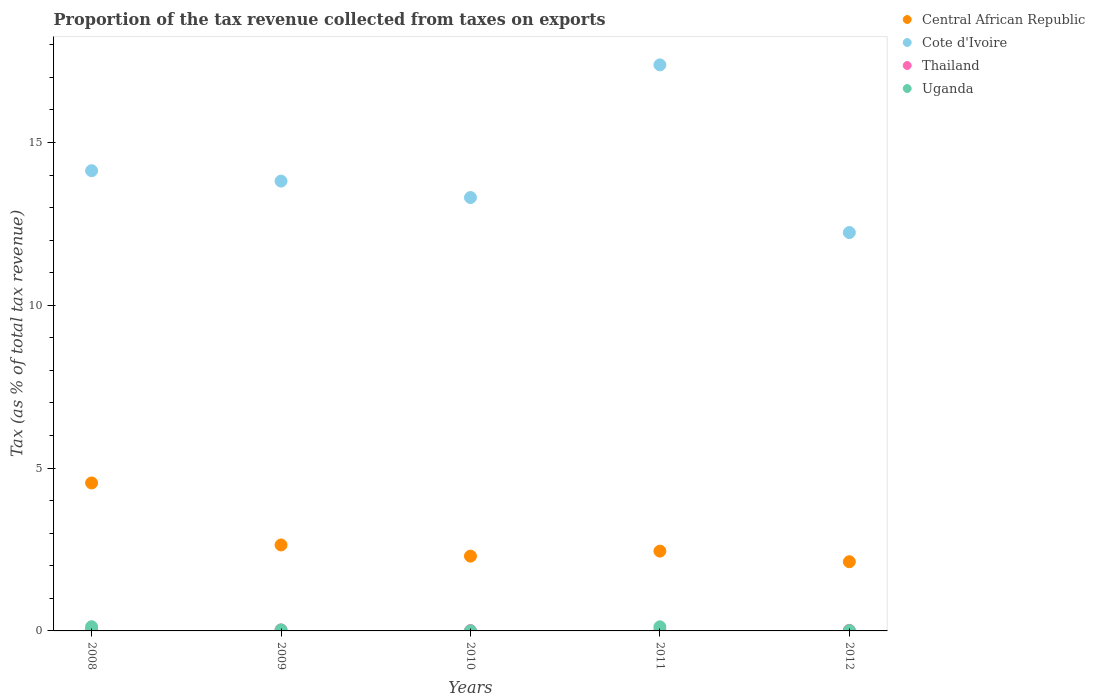What is the proportion of the tax revenue collected in Central African Republic in 2010?
Make the answer very short. 2.3. Across all years, what is the maximum proportion of the tax revenue collected in Uganda?
Your answer should be very brief. 0.13. Across all years, what is the minimum proportion of the tax revenue collected in Uganda?
Offer a very short reply. 0. In which year was the proportion of the tax revenue collected in Central African Republic minimum?
Offer a terse response. 2012. What is the total proportion of the tax revenue collected in Uganda in the graph?
Your answer should be compact. 0.3. What is the difference between the proportion of the tax revenue collected in Thailand in 2010 and that in 2012?
Provide a short and direct response. -0.01. What is the difference between the proportion of the tax revenue collected in Central African Republic in 2008 and the proportion of the tax revenue collected in Thailand in 2010?
Ensure brevity in your answer.  4.53. What is the average proportion of the tax revenue collected in Thailand per year?
Offer a very short reply. 0.02. In the year 2011, what is the difference between the proportion of the tax revenue collected in Uganda and proportion of the tax revenue collected in Thailand?
Provide a succinct answer. 0.11. In how many years, is the proportion of the tax revenue collected in Central African Republic greater than 8 %?
Your answer should be very brief. 0. What is the ratio of the proportion of the tax revenue collected in Uganda in 2009 to that in 2011?
Give a very brief answer. 0.25. Is the difference between the proportion of the tax revenue collected in Uganda in 2008 and 2010 greater than the difference between the proportion of the tax revenue collected in Thailand in 2008 and 2010?
Ensure brevity in your answer.  Yes. What is the difference between the highest and the second highest proportion of the tax revenue collected in Uganda?
Offer a terse response. 0. What is the difference between the highest and the lowest proportion of the tax revenue collected in Uganda?
Ensure brevity in your answer.  0.13. In how many years, is the proportion of the tax revenue collected in Central African Republic greater than the average proportion of the tax revenue collected in Central African Republic taken over all years?
Offer a very short reply. 1. Is the proportion of the tax revenue collected in Thailand strictly greater than the proportion of the tax revenue collected in Uganda over the years?
Ensure brevity in your answer.  No. What is the difference between two consecutive major ticks on the Y-axis?
Ensure brevity in your answer.  5. Are the values on the major ticks of Y-axis written in scientific E-notation?
Keep it short and to the point. No. Does the graph contain any zero values?
Give a very brief answer. No. Does the graph contain grids?
Provide a succinct answer. No. Where does the legend appear in the graph?
Provide a short and direct response. Top right. How many legend labels are there?
Make the answer very short. 4. How are the legend labels stacked?
Your answer should be very brief. Vertical. What is the title of the graph?
Make the answer very short. Proportion of the tax revenue collected from taxes on exports. Does "Maldives" appear as one of the legend labels in the graph?
Offer a terse response. No. What is the label or title of the Y-axis?
Keep it short and to the point. Tax (as % of total tax revenue). What is the Tax (as % of total tax revenue) of Central African Republic in 2008?
Ensure brevity in your answer.  4.54. What is the Tax (as % of total tax revenue) in Cote d'Ivoire in 2008?
Offer a terse response. 14.13. What is the Tax (as % of total tax revenue) in Thailand in 2008?
Your answer should be very brief. 0.03. What is the Tax (as % of total tax revenue) in Uganda in 2008?
Your answer should be compact. 0.13. What is the Tax (as % of total tax revenue) of Central African Republic in 2009?
Your response must be concise. 2.64. What is the Tax (as % of total tax revenue) of Cote d'Ivoire in 2009?
Ensure brevity in your answer.  13.81. What is the Tax (as % of total tax revenue) in Thailand in 2009?
Make the answer very short. 0.03. What is the Tax (as % of total tax revenue) in Uganda in 2009?
Offer a very short reply. 0.03. What is the Tax (as % of total tax revenue) of Central African Republic in 2010?
Ensure brevity in your answer.  2.3. What is the Tax (as % of total tax revenue) in Cote d'Ivoire in 2010?
Offer a very short reply. 13.31. What is the Tax (as % of total tax revenue) of Thailand in 2010?
Provide a short and direct response. 0.01. What is the Tax (as % of total tax revenue) in Uganda in 2010?
Your response must be concise. 0. What is the Tax (as % of total tax revenue) in Central African Republic in 2011?
Give a very brief answer. 2.45. What is the Tax (as % of total tax revenue) in Cote d'Ivoire in 2011?
Your answer should be very brief. 17.38. What is the Tax (as % of total tax revenue) in Thailand in 2011?
Give a very brief answer. 0.01. What is the Tax (as % of total tax revenue) in Uganda in 2011?
Offer a terse response. 0.13. What is the Tax (as % of total tax revenue) of Central African Republic in 2012?
Give a very brief answer. 2.13. What is the Tax (as % of total tax revenue) in Cote d'Ivoire in 2012?
Ensure brevity in your answer.  12.23. What is the Tax (as % of total tax revenue) in Thailand in 2012?
Provide a succinct answer. 0.02. What is the Tax (as % of total tax revenue) of Uganda in 2012?
Provide a short and direct response. 0.01. Across all years, what is the maximum Tax (as % of total tax revenue) in Central African Republic?
Your response must be concise. 4.54. Across all years, what is the maximum Tax (as % of total tax revenue) in Cote d'Ivoire?
Give a very brief answer. 17.38. Across all years, what is the maximum Tax (as % of total tax revenue) of Thailand?
Ensure brevity in your answer.  0.03. Across all years, what is the maximum Tax (as % of total tax revenue) of Uganda?
Provide a short and direct response. 0.13. Across all years, what is the minimum Tax (as % of total tax revenue) of Central African Republic?
Make the answer very short. 2.13. Across all years, what is the minimum Tax (as % of total tax revenue) of Cote d'Ivoire?
Provide a succinct answer. 12.23. Across all years, what is the minimum Tax (as % of total tax revenue) of Thailand?
Provide a short and direct response. 0.01. Across all years, what is the minimum Tax (as % of total tax revenue) in Uganda?
Your answer should be very brief. 0. What is the total Tax (as % of total tax revenue) in Central African Republic in the graph?
Provide a succinct answer. 14.06. What is the total Tax (as % of total tax revenue) in Cote d'Ivoire in the graph?
Keep it short and to the point. 70.88. What is the total Tax (as % of total tax revenue) in Thailand in the graph?
Make the answer very short. 0.1. What is the total Tax (as % of total tax revenue) of Uganda in the graph?
Your answer should be compact. 0.3. What is the difference between the Tax (as % of total tax revenue) in Central African Republic in 2008 and that in 2009?
Ensure brevity in your answer.  1.9. What is the difference between the Tax (as % of total tax revenue) of Cote d'Ivoire in 2008 and that in 2009?
Provide a short and direct response. 0.32. What is the difference between the Tax (as % of total tax revenue) of Thailand in 2008 and that in 2009?
Make the answer very short. 0. What is the difference between the Tax (as % of total tax revenue) of Uganda in 2008 and that in 2009?
Make the answer very short. 0.1. What is the difference between the Tax (as % of total tax revenue) of Central African Republic in 2008 and that in 2010?
Give a very brief answer. 2.25. What is the difference between the Tax (as % of total tax revenue) in Cote d'Ivoire in 2008 and that in 2010?
Ensure brevity in your answer.  0.82. What is the difference between the Tax (as % of total tax revenue) in Thailand in 2008 and that in 2010?
Your answer should be compact. 0.02. What is the difference between the Tax (as % of total tax revenue) in Uganda in 2008 and that in 2010?
Offer a terse response. 0.13. What is the difference between the Tax (as % of total tax revenue) of Central African Republic in 2008 and that in 2011?
Your response must be concise. 2.09. What is the difference between the Tax (as % of total tax revenue) in Cote d'Ivoire in 2008 and that in 2011?
Provide a succinct answer. -3.25. What is the difference between the Tax (as % of total tax revenue) in Thailand in 2008 and that in 2011?
Your answer should be compact. 0.02. What is the difference between the Tax (as % of total tax revenue) in Uganda in 2008 and that in 2011?
Keep it short and to the point. 0. What is the difference between the Tax (as % of total tax revenue) of Central African Republic in 2008 and that in 2012?
Give a very brief answer. 2.42. What is the difference between the Tax (as % of total tax revenue) in Cote d'Ivoire in 2008 and that in 2012?
Offer a very short reply. 1.9. What is the difference between the Tax (as % of total tax revenue) of Thailand in 2008 and that in 2012?
Your answer should be very brief. 0.02. What is the difference between the Tax (as % of total tax revenue) in Uganda in 2008 and that in 2012?
Provide a succinct answer. 0.12. What is the difference between the Tax (as % of total tax revenue) of Central African Republic in 2009 and that in 2010?
Your answer should be compact. 0.34. What is the difference between the Tax (as % of total tax revenue) of Cote d'Ivoire in 2009 and that in 2010?
Offer a very short reply. 0.5. What is the difference between the Tax (as % of total tax revenue) of Thailand in 2009 and that in 2010?
Your answer should be compact. 0.02. What is the difference between the Tax (as % of total tax revenue) of Uganda in 2009 and that in 2010?
Your answer should be compact. 0.03. What is the difference between the Tax (as % of total tax revenue) in Central African Republic in 2009 and that in 2011?
Keep it short and to the point. 0.19. What is the difference between the Tax (as % of total tax revenue) of Cote d'Ivoire in 2009 and that in 2011?
Make the answer very short. -3.57. What is the difference between the Tax (as % of total tax revenue) of Thailand in 2009 and that in 2011?
Ensure brevity in your answer.  0.02. What is the difference between the Tax (as % of total tax revenue) of Uganda in 2009 and that in 2011?
Provide a short and direct response. -0.09. What is the difference between the Tax (as % of total tax revenue) in Central African Republic in 2009 and that in 2012?
Your response must be concise. 0.51. What is the difference between the Tax (as % of total tax revenue) of Cote d'Ivoire in 2009 and that in 2012?
Make the answer very short. 1.58. What is the difference between the Tax (as % of total tax revenue) in Thailand in 2009 and that in 2012?
Keep it short and to the point. 0.01. What is the difference between the Tax (as % of total tax revenue) of Uganda in 2009 and that in 2012?
Your answer should be compact. 0.02. What is the difference between the Tax (as % of total tax revenue) in Central African Republic in 2010 and that in 2011?
Offer a very short reply. -0.15. What is the difference between the Tax (as % of total tax revenue) in Cote d'Ivoire in 2010 and that in 2011?
Give a very brief answer. -4.07. What is the difference between the Tax (as % of total tax revenue) of Thailand in 2010 and that in 2011?
Your answer should be very brief. -0. What is the difference between the Tax (as % of total tax revenue) of Uganda in 2010 and that in 2011?
Offer a very short reply. -0.12. What is the difference between the Tax (as % of total tax revenue) in Central African Republic in 2010 and that in 2012?
Your response must be concise. 0.17. What is the difference between the Tax (as % of total tax revenue) in Cote d'Ivoire in 2010 and that in 2012?
Ensure brevity in your answer.  1.08. What is the difference between the Tax (as % of total tax revenue) in Thailand in 2010 and that in 2012?
Your answer should be very brief. -0.01. What is the difference between the Tax (as % of total tax revenue) in Uganda in 2010 and that in 2012?
Offer a very short reply. -0.01. What is the difference between the Tax (as % of total tax revenue) of Central African Republic in 2011 and that in 2012?
Make the answer very short. 0.33. What is the difference between the Tax (as % of total tax revenue) in Cote d'Ivoire in 2011 and that in 2012?
Your response must be concise. 5.15. What is the difference between the Tax (as % of total tax revenue) in Thailand in 2011 and that in 2012?
Your answer should be very brief. -0. What is the difference between the Tax (as % of total tax revenue) in Uganda in 2011 and that in 2012?
Your answer should be compact. 0.12. What is the difference between the Tax (as % of total tax revenue) in Central African Republic in 2008 and the Tax (as % of total tax revenue) in Cote d'Ivoire in 2009?
Your response must be concise. -9.27. What is the difference between the Tax (as % of total tax revenue) in Central African Republic in 2008 and the Tax (as % of total tax revenue) in Thailand in 2009?
Give a very brief answer. 4.51. What is the difference between the Tax (as % of total tax revenue) in Central African Republic in 2008 and the Tax (as % of total tax revenue) in Uganda in 2009?
Offer a very short reply. 4.51. What is the difference between the Tax (as % of total tax revenue) in Cote d'Ivoire in 2008 and the Tax (as % of total tax revenue) in Thailand in 2009?
Offer a terse response. 14.1. What is the difference between the Tax (as % of total tax revenue) of Cote d'Ivoire in 2008 and the Tax (as % of total tax revenue) of Uganda in 2009?
Provide a succinct answer. 14.1. What is the difference between the Tax (as % of total tax revenue) of Thailand in 2008 and the Tax (as % of total tax revenue) of Uganda in 2009?
Provide a succinct answer. 0. What is the difference between the Tax (as % of total tax revenue) of Central African Republic in 2008 and the Tax (as % of total tax revenue) of Cote d'Ivoire in 2010?
Give a very brief answer. -8.77. What is the difference between the Tax (as % of total tax revenue) in Central African Republic in 2008 and the Tax (as % of total tax revenue) in Thailand in 2010?
Ensure brevity in your answer.  4.53. What is the difference between the Tax (as % of total tax revenue) in Central African Republic in 2008 and the Tax (as % of total tax revenue) in Uganda in 2010?
Your answer should be compact. 4.54. What is the difference between the Tax (as % of total tax revenue) of Cote d'Ivoire in 2008 and the Tax (as % of total tax revenue) of Thailand in 2010?
Keep it short and to the point. 14.12. What is the difference between the Tax (as % of total tax revenue) of Cote d'Ivoire in 2008 and the Tax (as % of total tax revenue) of Uganda in 2010?
Your answer should be very brief. 14.13. What is the difference between the Tax (as % of total tax revenue) of Thailand in 2008 and the Tax (as % of total tax revenue) of Uganda in 2010?
Provide a succinct answer. 0.03. What is the difference between the Tax (as % of total tax revenue) of Central African Republic in 2008 and the Tax (as % of total tax revenue) of Cote d'Ivoire in 2011?
Give a very brief answer. -12.84. What is the difference between the Tax (as % of total tax revenue) of Central African Republic in 2008 and the Tax (as % of total tax revenue) of Thailand in 2011?
Your answer should be compact. 4.53. What is the difference between the Tax (as % of total tax revenue) of Central African Republic in 2008 and the Tax (as % of total tax revenue) of Uganda in 2011?
Keep it short and to the point. 4.42. What is the difference between the Tax (as % of total tax revenue) of Cote d'Ivoire in 2008 and the Tax (as % of total tax revenue) of Thailand in 2011?
Make the answer very short. 14.12. What is the difference between the Tax (as % of total tax revenue) of Cote d'Ivoire in 2008 and the Tax (as % of total tax revenue) of Uganda in 2011?
Make the answer very short. 14.01. What is the difference between the Tax (as % of total tax revenue) in Thailand in 2008 and the Tax (as % of total tax revenue) in Uganda in 2011?
Your answer should be compact. -0.09. What is the difference between the Tax (as % of total tax revenue) in Central African Republic in 2008 and the Tax (as % of total tax revenue) in Cote d'Ivoire in 2012?
Keep it short and to the point. -7.69. What is the difference between the Tax (as % of total tax revenue) in Central African Republic in 2008 and the Tax (as % of total tax revenue) in Thailand in 2012?
Ensure brevity in your answer.  4.53. What is the difference between the Tax (as % of total tax revenue) in Central African Republic in 2008 and the Tax (as % of total tax revenue) in Uganda in 2012?
Make the answer very short. 4.54. What is the difference between the Tax (as % of total tax revenue) in Cote d'Ivoire in 2008 and the Tax (as % of total tax revenue) in Thailand in 2012?
Offer a terse response. 14.12. What is the difference between the Tax (as % of total tax revenue) in Cote d'Ivoire in 2008 and the Tax (as % of total tax revenue) in Uganda in 2012?
Offer a very short reply. 14.12. What is the difference between the Tax (as % of total tax revenue) of Thailand in 2008 and the Tax (as % of total tax revenue) of Uganda in 2012?
Make the answer very short. 0.02. What is the difference between the Tax (as % of total tax revenue) in Central African Republic in 2009 and the Tax (as % of total tax revenue) in Cote d'Ivoire in 2010?
Your answer should be very brief. -10.67. What is the difference between the Tax (as % of total tax revenue) in Central African Republic in 2009 and the Tax (as % of total tax revenue) in Thailand in 2010?
Keep it short and to the point. 2.63. What is the difference between the Tax (as % of total tax revenue) in Central African Republic in 2009 and the Tax (as % of total tax revenue) in Uganda in 2010?
Provide a short and direct response. 2.64. What is the difference between the Tax (as % of total tax revenue) in Cote d'Ivoire in 2009 and the Tax (as % of total tax revenue) in Thailand in 2010?
Give a very brief answer. 13.8. What is the difference between the Tax (as % of total tax revenue) of Cote d'Ivoire in 2009 and the Tax (as % of total tax revenue) of Uganda in 2010?
Your answer should be very brief. 13.81. What is the difference between the Tax (as % of total tax revenue) of Thailand in 2009 and the Tax (as % of total tax revenue) of Uganda in 2010?
Provide a short and direct response. 0.03. What is the difference between the Tax (as % of total tax revenue) in Central African Republic in 2009 and the Tax (as % of total tax revenue) in Cote d'Ivoire in 2011?
Make the answer very short. -14.74. What is the difference between the Tax (as % of total tax revenue) in Central African Republic in 2009 and the Tax (as % of total tax revenue) in Thailand in 2011?
Give a very brief answer. 2.63. What is the difference between the Tax (as % of total tax revenue) of Central African Republic in 2009 and the Tax (as % of total tax revenue) of Uganda in 2011?
Give a very brief answer. 2.51. What is the difference between the Tax (as % of total tax revenue) of Cote d'Ivoire in 2009 and the Tax (as % of total tax revenue) of Thailand in 2011?
Provide a short and direct response. 13.8. What is the difference between the Tax (as % of total tax revenue) in Cote d'Ivoire in 2009 and the Tax (as % of total tax revenue) in Uganda in 2011?
Your response must be concise. 13.69. What is the difference between the Tax (as % of total tax revenue) of Thailand in 2009 and the Tax (as % of total tax revenue) of Uganda in 2011?
Give a very brief answer. -0.1. What is the difference between the Tax (as % of total tax revenue) of Central African Republic in 2009 and the Tax (as % of total tax revenue) of Cote d'Ivoire in 2012?
Your answer should be compact. -9.59. What is the difference between the Tax (as % of total tax revenue) in Central African Republic in 2009 and the Tax (as % of total tax revenue) in Thailand in 2012?
Ensure brevity in your answer.  2.62. What is the difference between the Tax (as % of total tax revenue) of Central African Republic in 2009 and the Tax (as % of total tax revenue) of Uganda in 2012?
Offer a terse response. 2.63. What is the difference between the Tax (as % of total tax revenue) in Cote d'Ivoire in 2009 and the Tax (as % of total tax revenue) in Thailand in 2012?
Your response must be concise. 13.8. What is the difference between the Tax (as % of total tax revenue) of Cote d'Ivoire in 2009 and the Tax (as % of total tax revenue) of Uganda in 2012?
Your answer should be compact. 13.81. What is the difference between the Tax (as % of total tax revenue) in Thailand in 2009 and the Tax (as % of total tax revenue) in Uganda in 2012?
Your answer should be very brief. 0.02. What is the difference between the Tax (as % of total tax revenue) in Central African Republic in 2010 and the Tax (as % of total tax revenue) in Cote d'Ivoire in 2011?
Provide a succinct answer. -15.09. What is the difference between the Tax (as % of total tax revenue) of Central African Republic in 2010 and the Tax (as % of total tax revenue) of Thailand in 2011?
Provide a short and direct response. 2.28. What is the difference between the Tax (as % of total tax revenue) in Central African Republic in 2010 and the Tax (as % of total tax revenue) in Uganda in 2011?
Your answer should be compact. 2.17. What is the difference between the Tax (as % of total tax revenue) in Cote d'Ivoire in 2010 and the Tax (as % of total tax revenue) in Thailand in 2011?
Give a very brief answer. 13.3. What is the difference between the Tax (as % of total tax revenue) in Cote d'Ivoire in 2010 and the Tax (as % of total tax revenue) in Uganda in 2011?
Offer a terse response. 13.18. What is the difference between the Tax (as % of total tax revenue) in Thailand in 2010 and the Tax (as % of total tax revenue) in Uganda in 2011?
Provide a short and direct response. -0.12. What is the difference between the Tax (as % of total tax revenue) of Central African Republic in 2010 and the Tax (as % of total tax revenue) of Cote d'Ivoire in 2012?
Your response must be concise. -9.94. What is the difference between the Tax (as % of total tax revenue) of Central African Republic in 2010 and the Tax (as % of total tax revenue) of Thailand in 2012?
Offer a terse response. 2.28. What is the difference between the Tax (as % of total tax revenue) of Central African Republic in 2010 and the Tax (as % of total tax revenue) of Uganda in 2012?
Your response must be concise. 2.29. What is the difference between the Tax (as % of total tax revenue) in Cote d'Ivoire in 2010 and the Tax (as % of total tax revenue) in Thailand in 2012?
Make the answer very short. 13.29. What is the difference between the Tax (as % of total tax revenue) in Cote d'Ivoire in 2010 and the Tax (as % of total tax revenue) in Uganda in 2012?
Your response must be concise. 13.3. What is the difference between the Tax (as % of total tax revenue) of Thailand in 2010 and the Tax (as % of total tax revenue) of Uganda in 2012?
Ensure brevity in your answer.  0. What is the difference between the Tax (as % of total tax revenue) of Central African Republic in 2011 and the Tax (as % of total tax revenue) of Cote d'Ivoire in 2012?
Give a very brief answer. -9.78. What is the difference between the Tax (as % of total tax revenue) of Central African Republic in 2011 and the Tax (as % of total tax revenue) of Thailand in 2012?
Give a very brief answer. 2.43. What is the difference between the Tax (as % of total tax revenue) of Central African Republic in 2011 and the Tax (as % of total tax revenue) of Uganda in 2012?
Keep it short and to the point. 2.44. What is the difference between the Tax (as % of total tax revenue) in Cote d'Ivoire in 2011 and the Tax (as % of total tax revenue) in Thailand in 2012?
Make the answer very short. 17.37. What is the difference between the Tax (as % of total tax revenue) in Cote d'Ivoire in 2011 and the Tax (as % of total tax revenue) in Uganda in 2012?
Your answer should be compact. 17.38. What is the difference between the Tax (as % of total tax revenue) in Thailand in 2011 and the Tax (as % of total tax revenue) in Uganda in 2012?
Your response must be concise. 0. What is the average Tax (as % of total tax revenue) in Central African Republic per year?
Give a very brief answer. 2.81. What is the average Tax (as % of total tax revenue) in Cote d'Ivoire per year?
Your answer should be compact. 14.18. What is the average Tax (as % of total tax revenue) in Thailand per year?
Offer a terse response. 0.02. What is the average Tax (as % of total tax revenue) of Uganda per year?
Ensure brevity in your answer.  0.06. In the year 2008, what is the difference between the Tax (as % of total tax revenue) of Central African Republic and Tax (as % of total tax revenue) of Cote d'Ivoire?
Your response must be concise. -9.59. In the year 2008, what is the difference between the Tax (as % of total tax revenue) in Central African Republic and Tax (as % of total tax revenue) in Thailand?
Provide a succinct answer. 4.51. In the year 2008, what is the difference between the Tax (as % of total tax revenue) in Central African Republic and Tax (as % of total tax revenue) in Uganda?
Keep it short and to the point. 4.42. In the year 2008, what is the difference between the Tax (as % of total tax revenue) of Cote d'Ivoire and Tax (as % of total tax revenue) of Thailand?
Give a very brief answer. 14.1. In the year 2008, what is the difference between the Tax (as % of total tax revenue) in Cote d'Ivoire and Tax (as % of total tax revenue) in Uganda?
Provide a short and direct response. 14. In the year 2008, what is the difference between the Tax (as % of total tax revenue) of Thailand and Tax (as % of total tax revenue) of Uganda?
Your answer should be compact. -0.1. In the year 2009, what is the difference between the Tax (as % of total tax revenue) in Central African Republic and Tax (as % of total tax revenue) in Cote d'Ivoire?
Ensure brevity in your answer.  -11.17. In the year 2009, what is the difference between the Tax (as % of total tax revenue) in Central African Republic and Tax (as % of total tax revenue) in Thailand?
Your answer should be compact. 2.61. In the year 2009, what is the difference between the Tax (as % of total tax revenue) of Central African Republic and Tax (as % of total tax revenue) of Uganda?
Offer a very short reply. 2.61. In the year 2009, what is the difference between the Tax (as % of total tax revenue) in Cote d'Ivoire and Tax (as % of total tax revenue) in Thailand?
Give a very brief answer. 13.79. In the year 2009, what is the difference between the Tax (as % of total tax revenue) in Cote d'Ivoire and Tax (as % of total tax revenue) in Uganda?
Make the answer very short. 13.78. In the year 2009, what is the difference between the Tax (as % of total tax revenue) in Thailand and Tax (as % of total tax revenue) in Uganda?
Provide a short and direct response. -0. In the year 2010, what is the difference between the Tax (as % of total tax revenue) of Central African Republic and Tax (as % of total tax revenue) of Cote d'Ivoire?
Give a very brief answer. -11.01. In the year 2010, what is the difference between the Tax (as % of total tax revenue) in Central African Republic and Tax (as % of total tax revenue) in Thailand?
Keep it short and to the point. 2.29. In the year 2010, what is the difference between the Tax (as % of total tax revenue) in Central African Republic and Tax (as % of total tax revenue) in Uganda?
Offer a terse response. 2.29. In the year 2010, what is the difference between the Tax (as % of total tax revenue) in Cote d'Ivoire and Tax (as % of total tax revenue) in Thailand?
Your response must be concise. 13.3. In the year 2010, what is the difference between the Tax (as % of total tax revenue) in Cote d'Ivoire and Tax (as % of total tax revenue) in Uganda?
Offer a very short reply. 13.31. In the year 2010, what is the difference between the Tax (as % of total tax revenue) of Thailand and Tax (as % of total tax revenue) of Uganda?
Keep it short and to the point. 0.01. In the year 2011, what is the difference between the Tax (as % of total tax revenue) in Central African Republic and Tax (as % of total tax revenue) in Cote d'Ivoire?
Your answer should be compact. -14.93. In the year 2011, what is the difference between the Tax (as % of total tax revenue) in Central African Republic and Tax (as % of total tax revenue) in Thailand?
Offer a terse response. 2.44. In the year 2011, what is the difference between the Tax (as % of total tax revenue) of Central African Republic and Tax (as % of total tax revenue) of Uganda?
Ensure brevity in your answer.  2.32. In the year 2011, what is the difference between the Tax (as % of total tax revenue) of Cote d'Ivoire and Tax (as % of total tax revenue) of Thailand?
Offer a terse response. 17.37. In the year 2011, what is the difference between the Tax (as % of total tax revenue) of Cote d'Ivoire and Tax (as % of total tax revenue) of Uganda?
Your response must be concise. 17.26. In the year 2011, what is the difference between the Tax (as % of total tax revenue) of Thailand and Tax (as % of total tax revenue) of Uganda?
Give a very brief answer. -0.11. In the year 2012, what is the difference between the Tax (as % of total tax revenue) in Central African Republic and Tax (as % of total tax revenue) in Cote d'Ivoire?
Your answer should be very brief. -10.11. In the year 2012, what is the difference between the Tax (as % of total tax revenue) of Central African Republic and Tax (as % of total tax revenue) of Thailand?
Your response must be concise. 2.11. In the year 2012, what is the difference between the Tax (as % of total tax revenue) in Central African Republic and Tax (as % of total tax revenue) in Uganda?
Ensure brevity in your answer.  2.12. In the year 2012, what is the difference between the Tax (as % of total tax revenue) in Cote d'Ivoire and Tax (as % of total tax revenue) in Thailand?
Offer a very short reply. 12.22. In the year 2012, what is the difference between the Tax (as % of total tax revenue) of Cote d'Ivoire and Tax (as % of total tax revenue) of Uganda?
Ensure brevity in your answer.  12.23. In the year 2012, what is the difference between the Tax (as % of total tax revenue) in Thailand and Tax (as % of total tax revenue) in Uganda?
Your answer should be very brief. 0.01. What is the ratio of the Tax (as % of total tax revenue) in Central African Republic in 2008 to that in 2009?
Give a very brief answer. 1.72. What is the ratio of the Tax (as % of total tax revenue) in Cote d'Ivoire in 2008 to that in 2009?
Your response must be concise. 1.02. What is the ratio of the Tax (as % of total tax revenue) in Thailand in 2008 to that in 2009?
Your response must be concise. 1.15. What is the ratio of the Tax (as % of total tax revenue) in Uganda in 2008 to that in 2009?
Offer a terse response. 4.15. What is the ratio of the Tax (as % of total tax revenue) in Central African Republic in 2008 to that in 2010?
Provide a short and direct response. 1.98. What is the ratio of the Tax (as % of total tax revenue) of Cote d'Ivoire in 2008 to that in 2010?
Your response must be concise. 1.06. What is the ratio of the Tax (as % of total tax revenue) of Thailand in 2008 to that in 2010?
Keep it short and to the point. 3.23. What is the ratio of the Tax (as % of total tax revenue) in Uganda in 2008 to that in 2010?
Keep it short and to the point. 44.5. What is the ratio of the Tax (as % of total tax revenue) of Central African Republic in 2008 to that in 2011?
Provide a succinct answer. 1.85. What is the ratio of the Tax (as % of total tax revenue) in Cote d'Ivoire in 2008 to that in 2011?
Make the answer very short. 0.81. What is the ratio of the Tax (as % of total tax revenue) of Thailand in 2008 to that in 2011?
Your answer should be compact. 2.59. What is the ratio of the Tax (as % of total tax revenue) of Uganda in 2008 to that in 2011?
Your response must be concise. 1.02. What is the ratio of the Tax (as % of total tax revenue) in Central African Republic in 2008 to that in 2012?
Provide a short and direct response. 2.14. What is the ratio of the Tax (as % of total tax revenue) of Cote d'Ivoire in 2008 to that in 2012?
Make the answer very short. 1.16. What is the ratio of the Tax (as % of total tax revenue) of Thailand in 2008 to that in 2012?
Make the answer very short. 1.96. What is the ratio of the Tax (as % of total tax revenue) in Uganda in 2008 to that in 2012?
Keep it short and to the point. 14.35. What is the ratio of the Tax (as % of total tax revenue) of Central African Republic in 2009 to that in 2010?
Your answer should be compact. 1.15. What is the ratio of the Tax (as % of total tax revenue) of Cote d'Ivoire in 2009 to that in 2010?
Give a very brief answer. 1.04. What is the ratio of the Tax (as % of total tax revenue) in Thailand in 2009 to that in 2010?
Give a very brief answer. 2.81. What is the ratio of the Tax (as % of total tax revenue) of Uganda in 2009 to that in 2010?
Your response must be concise. 10.72. What is the ratio of the Tax (as % of total tax revenue) of Central African Republic in 2009 to that in 2011?
Make the answer very short. 1.08. What is the ratio of the Tax (as % of total tax revenue) of Cote d'Ivoire in 2009 to that in 2011?
Keep it short and to the point. 0.79. What is the ratio of the Tax (as % of total tax revenue) in Thailand in 2009 to that in 2011?
Provide a succinct answer. 2.26. What is the ratio of the Tax (as % of total tax revenue) of Uganda in 2009 to that in 2011?
Your answer should be very brief. 0.25. What is the ratio of the Tax (as % of total tax revenue) of Central African Republic in 2009 to that in 2012?
Your answer should be compact. 1.24. What is the ratio of the Tax (as % of total tax revenue) in Cote d'Ivoire in 2009 to that in 2012?
Your answer should be very brief. 1.13. What is the ratio of the Tax (as % of total tax revenue) in Thailand in 2009 to that in 2012?
Your response must be concise. 1.71. What is the ratio of the Tax (as % of total tax revenue) in Uganda in 2009 to that in 2012?
Offer a terse response. 3.46. What is the ratio of the Tax (as % of total tax revenue) of Central African Republic in 2010 to that in 2011?
Your response must be concise. 0.94. What is the ratio of the Tax (as % of total tax revenue) of Cote d'Ivoire in 2010 to that in 2011?
Your response must be concise. 0.77. What is the ratio of the Tax (as % of total tax revenue) in Thailand in 2010 to that in 2011?
Provide a short and direct response. 0.8. What is the ratio of the Tax (as % of total tax revenue) in Uganda in 2010 to that in 2011?
Offer a very short reply. 0.02. What is the ratio of the Tax (as % of total tax revenue) in Central African Republic in 2010 to that in 2012?
Keep it short and to the point. 1.08. What is the ratio of the Tax (as % of total tax revenue) of Cote d'Ivoire in 2010 to that in 2012?
Offer a very short reply. 1.09. What is the ratio of the Tax (as % of total tax revenue) of Thailand in 2010 to that in 2012?
Your answer should be very brief. 0.61. What is the ratio of the Tax (as % of total tax revenue) of Uganda in 2010 to that in 2012?
Your response must be concise. 0.32. What is the ratio of the Tax (as % of total tax revenue) in Central African Republic in 2011 to that in 2012?
Give a very brief answer. 1.15. What is the ratio of the Tax (as % of total tax revenue) of Cote d'Ivoire in 2011 to that in 2012?
Your answer should be compact. 1.42. What is the ratio of the Tax (as % of total tax revenue) in Thailand in 2011 to that in 2012?
Your answer should be compact. 0.76. What is the ratio of the Tax (as % of total tax revenue) of Uganda in 2011 to that in 2012?
Provide a short and direct response. 14.01. What is the difference between the highest and the second highest Tax (as % of total tax revenue) in Central African Republic?
Your answer should be compact. 1.9. What is the difference between the highest and the second highest Tax (as % of total tax revenue) in Cote d'Ivoire?
Provide a short and direct response. 3.25. What is the difference between the highest and the second highest Tax (as % of total tax revenue) in Thailand?
Ensure brevity in your answer.  0. What is the difference between the highest and the second highest Tax (as % of total tax revenue) of Uganda?
Your answer should be very brief. 0. What is the difference between the highest and the lowest Tax (as % of total tax revenue) of Central African Republic?
Offer a very short reply. 2.42. What is the difference between the highest and the lowest Tax (as % of total tax revenue) of Cote d'Ivoire?
Your answer should be compact. 5.15. What is the difference between the highest and the lowest Tax (as % of total tax revenue) of Thailand?
Give a very brief answer. 0.02. What is the difference between the highest and the lowest Tax (as % of total tax revenue) in Uganda?
Offer a very short reply. 0.13. 